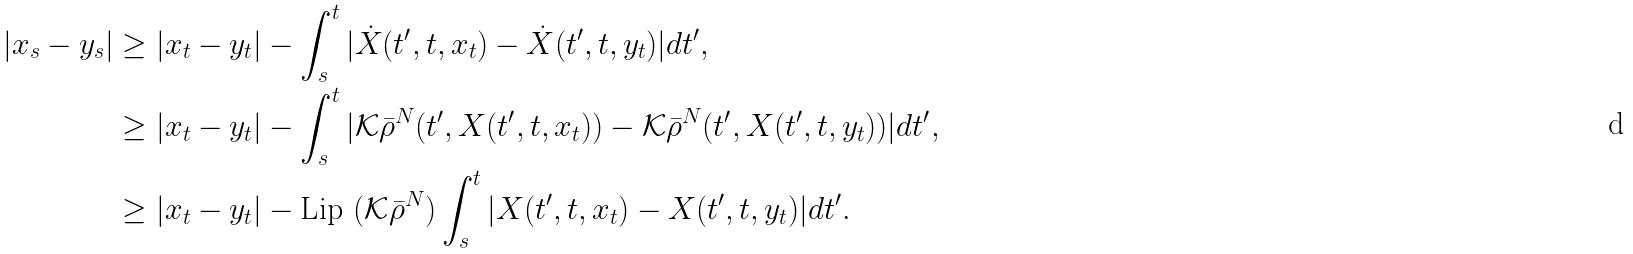<formula> <loc_0><loc_0><loc_500><loc_500>| x _ { s } - y _ { s } | & \geq | x _ { t } - y _ { t } | - \int _ { s } ^ { t } | \dot { X } ( t ^ { \prime } , t , x _ { t } ) - \dot { X } ( t ^ { \prime } , t , y _ { t } ) | d t ^ { \prime } , \\ & \geq | x _ { t } - y _ { t } | - \int _ { s } ^ { t } | \mathcal { K } \bar { \rho } ^ { N } ( t ^ { \prime } , X ( t ^ { \prime } , t , x _ { t } ) ) - \mathcal { K } \bar { \rho } ^ { N } ( t ^ { \prime } , X ( t ^ { \prime } , t , y _ { t } ) ) | d t ^ { \prime } , \\ & \geq | x _ { t } - y _ { t } | - \text {Lip } ( \mathcal { K } \bar { \rho } ^ { N } ) \int _ { s } ^ { t } | X ( t ^ { \prime } , t , x _ { t } ) - X ( t ^ { \prime } , t , y _ { t } ) | d t ^ { \prime } .</formula> 